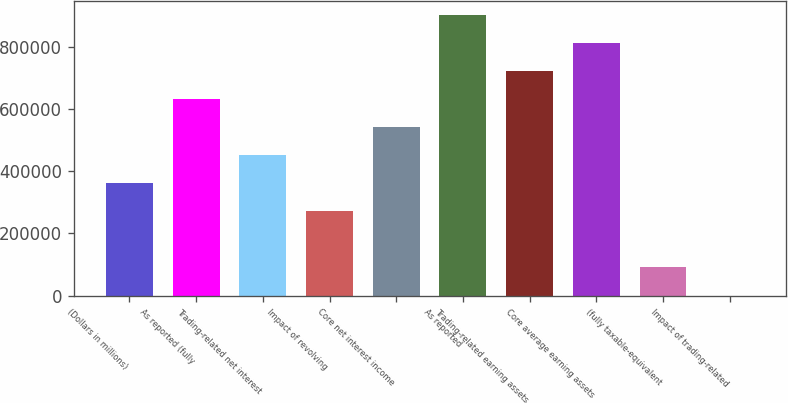<chart> <loc_0><loc_0><loc_500><loc_500><bar_chart><fcel>(Dollars in millions)<fcel>As reported (fully<fcel>Trading-related net interest<fcel>Impact of revolving<fcel>Core net interest income<fcel>As reported<fcel>Trading-related earning assets<fcel>Core average earning assets<fcel>(fully taxable-equivalent<fcel>Impact of trading-related<nl><fcel>362121<fcel>633712<fcel>452651<fcel>271591<fcel>543182<fcel>905302<fcel>724242<fcel>814772<fcel>90530.9<fcel>0.8<nl></chart> 